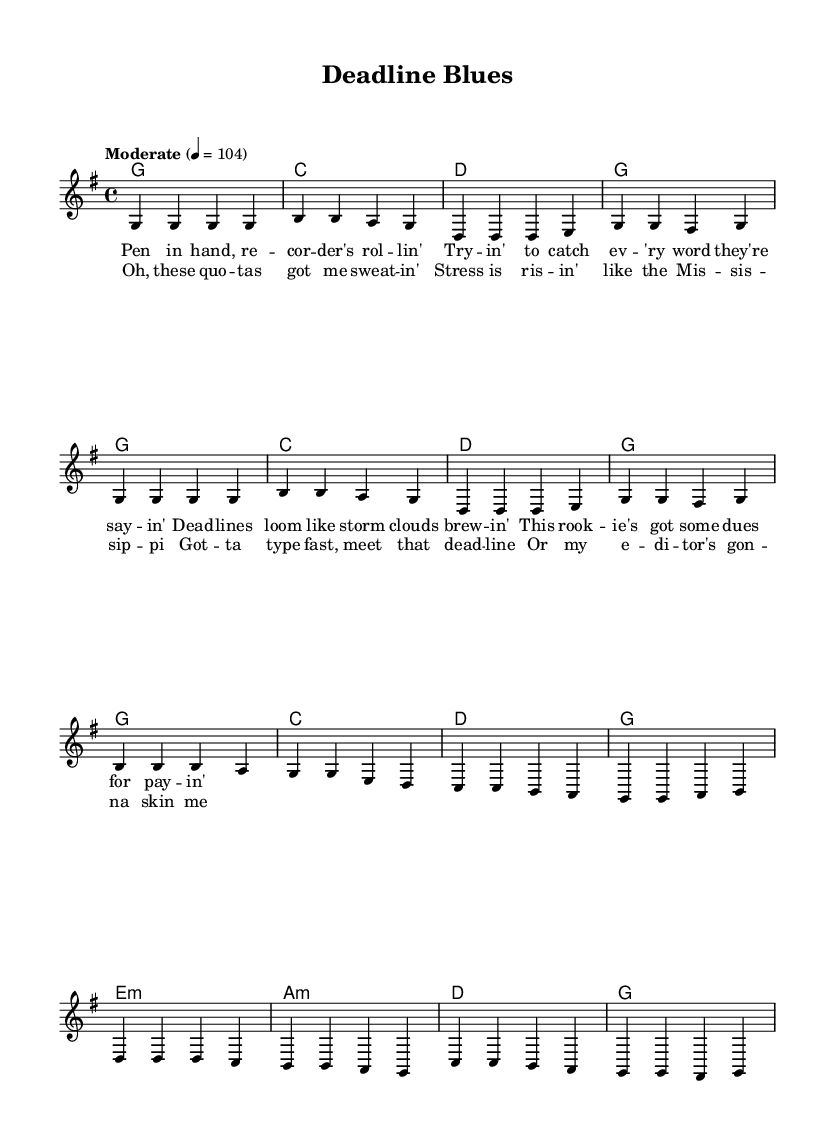What is the key signature of this music? The key signature is indicated by the absence of sharps or flats at the beginning of the staff. Since there are no symbols, it means the key is G major, which typically contains one sharp (F#), but is displayed here without explicit notation.
Answer: G major What is the time signature of this music? The time signature appears at the beginning of the staff; it is shown as a "4/4" sign, which means there are four beats per measure, and the quarter note receives one beat.
Answer: 4/4 What is the tempo marking for this piece? The tempo marking is given as "Moderate" with a metronome marking of 4 = 104, indicating how fast the music should be played. This shows the beats per minute.
Answer: Moderate 4 = 104 How many measures are there in the chorus section? By counting the measures in the chorus part of the score, it includes eight distinct measures, as indicated by the bar lines.
Answer: 8 What emotional theme is expressed in the lyrics? The lyrics mention "stress," "quotas," and "deadlines," which convey feelings of pressure and anxiety related to work and deadlines. This aligns with common country themes about life struggles.
Answer: Stress Which musical mode is primarily utilized in this composition? Observing the harmony section, it is mostly in a major chord structure, focusing on the G major chord, indicating it has a bright and uplifting sound typical for country music.
Answer: Major 